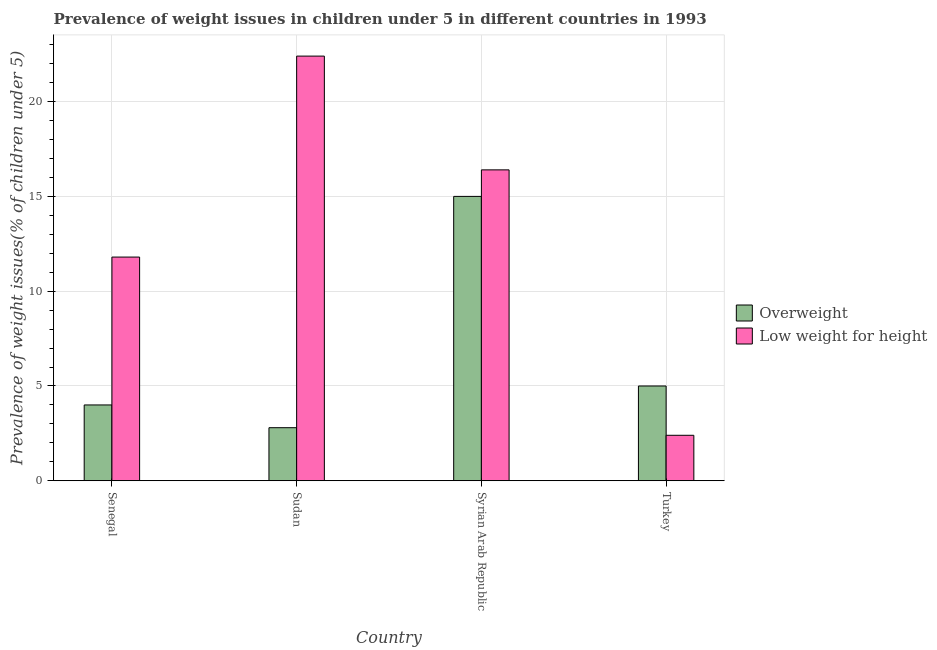Are the number of bars per tick equal to the number of legend labels?
Your answer should be very brief. Yes. Are the number of bars on each tick of the X-axis equal?
Your answer should be very brief. Yes. How many bars are there on the 1st tick from the left?
Your answer should be compact. 2. What is the label of the 4th group of bars from the left?
Keep it short and to the point. Turkey. In how many cases, is the number of bars for a given country not equal to the number of legend labels?
Your answer should be very brief. 0. Across all countries, what is the maximum percentage of overweight children?
Your response must be concise. 15. Across all countries, what is the minimum percentage of underweight children?
Your answer should be compact. 2.4. In which country was the percentage of underweight children maximum?
Provide a short and direct response. Sudan. In which country was the percentage of underweight children minimum?
Offer a very short reply. Turkey. What is the total percentage of underweight children in the graph?
Provide a succinct answer. 53. What is the difference between the percentage of overweight children in Senegal and that in Syrian Arab Republic?
Provide a short and direct response. -11. What is the difference between the percentage of underweight children in Sudan and the percentage of overweight children in Turkey?
Offer a very short reply. 17.4. What is the average percentage of overweight children per country?
Your answer should be very brief. 6.7. What is the difference between the percentage of underweight children and percentage of overweight children in Turkey?
Offer a very short reply. -2.6. What is the ratio of the percentage of overweight children in Senegal to that in Sudan?
Ensure brevity in your answer.  1.43. Is the difference between the percentage of underweight children in Senegal and Sudan greater than the difference between the percentage of overweight children in Senegal and Sudan?
Your answer should be compact. No. What is the difference between the highest and the lowest percentage of overweight children?
Ensure brevity in your answer.  12.2. What does the 1st bar from the left in Sudan represents?
Your response must be concise. Overweight. What does the 2nd bar from the right in Sudan represents?
Provide a succinct answer. Overweight. How many countries are there in the graph?
Ensure brevity in your answer.  4. What is the difference between two consecutive major ticks on the Y-axis?
Provide a short and direct response. 5. Are the values on the major ticks of Y-axis written in scientific E-notation?
Make the answer very short. No. Does the graph contain any zero values?
Offer a very short reply. No. Does the graph contain grids?
Your answer should be very brief. Yes. Where does the legend appear in the graph?
Your answer should be compact. Center right. How many legend labels are there?
Your answer should be very brief. 2. What is the title of the graph?
Ensure brevity in your answer.  Prevalence of weight issues in children under 5 in different countries in 1993. What is the label or title of the Y-axis?
Make the answer very short. Prevalence of weight issues(% of children under 5). What is the Prevalence of weight issues(% of children under 5) of Low weight for height in Senegal?
Offer a terse response. 11.8. What is the Prevalence of weight issues(% of children under 5) in Overweight in Sudan?
Your answer should be compact. 2.8. What is the Prevalence of weight issues(% of children under 5) in Low weight for height in Sudan?
Offer a very short reply. 22.4. What is the Prevalence of weight issues(% of children under 5) of Overweight in Syrian Arab Republic?
Your response must be concise. 15. What is the Prevalence of weight issues(% of children under 5) in Low weight for height in Syrian Arab Republic?
Your answer should be compact. 16.4. What is the Prevalence of weight issues(% of children under 5) of Low weight for height in Turkey?
Ensure brevity in your answer.  2.4. Across all countries, what is the maximum Prevalence of weight issues(% of children under 5) of Overweight?
Your answer should be compact. 15. Across all countries, what is the maximum Prevalence of weight issues(% of children under 5) of Low weight for height?
Your answer should be compact. 22.4. Across all countries, what is the minimum Prevalence of weight issues(% of children under 5) of Overweight?
Offer a terse response. 2.8. Across all countries, what is the minimum Prevalence of weight issues(% of children under 5) of Low weight for height?
Make the answer very short. 2.4. What is the total Prevalence of weight issues(% of children under 5) of Overweight in the graph?
Give a very brief answer. 26.8. What is the total Prevalence of weight issues(% of children under 5) in Low weight for height in the graph?
Keep it short and to the point. 53. What is the difference between the Prevalence of weight issues(% of children under 5) of Overweight in Senegal and that in Syrian Arab Republic?
Your answer should be compact. -11. What is the difference between the Prevalence of weight issues(% of children under 5) of Low weight for height in Senegal and that in Syrian Arab Republic?
Offer a terse response. -4.6. What is the difference between the Prevalence of weight issues(% of children under 5) in Overweight in Sudan and that in Syrian Arab Republic?
Make the answer very short. -12.2. What is the difference between the Prevalence of weight issues(% of children under 5) of Overweight in Sudan and that in Turkey?
Ensure brevity in your answer.  -2.2. What is the difference between the Prevalence of weight issues(% of children under 5) of Low weight for height in Sudan and that in Turkey?
Your answer should be compact. 20. What is the difference between the Prevalence of weight issues(% of children under 5) of Overweight in Senegal and the Prevalence of weight issues(% of children under 5) of Low weight for height in Sudan?
Provide a succinct answer. -18.4. What is the difference between the Prevalence of weight issues(% of children under 5) in Overweight in Sudan and the Prevalence of weight issues(% of children under 5) in Low weight for height in Turkey?
Ensure brevity in your answer.  0.4. What is the difference between the Prevalence of weight issues(% of children under 5) of Overweight in Syrian Arab Republic and the Prevalence of weight issues(% of children under 5) of Low weight for height in Turkey?
Offer a very short reply. 12.6. What is the average Prevalence of weight issues(% of children under 5) in Low weight for height per country?
Keep it short and to the point. 13.25. What is the difference between the Prevalence of weight issues(% of children under 5) in Overweight and Prevalence of weight issues(% of children under 5) in Low weight for height in Senegal?
Offer a terse response. -7.8. What is the difference between the Prevalence of weight issues(% of children under 5) in Overweight and Prevalence of weight issues(% of children under 5) in Low weight for height in Sudan?
Make the answer very short. -19.6. What is the ratio of the Prevalence of weight issues(% of children under 5) in Overweight in Senegal to that in Sudan?
Your answer should be compact. 1.43. What is the ratio of the Prevalence of weight issues(% of children under 5) of Low weight for height in Senegal to that in Sudan?
Give a very brief answer. 0.53. What is the ratio of the Prevalence of weight issues(% of children under 5) of Overweight in Senegal to that in Syrian Arab Republic?
Provide a short and direct response. 0.27. What is the ratio of the Prevalence of weight issues(% of children under 5) of Low weight for height in Senegal to that in Syrian Arab Republic?
Offer a terse response. 0.72. What is the ratio of the Prevalence of weight issues(% of children under 5) of Overweight in Senegal to that in Turkey?
Offer a very short reply. 0.8. What is the ratio of the Prevalence of weight issues(% of children under 5) of Low weight for height in Senegal to that in Turkey?
Give a very brief answer. 4.92. What is the ratio of the Prevalence of weight issues(% of children under 5) in Overweight in Sudan to that in Syrian Arab Republic?
Make the answer very short. 0.19. What is the ratio of the Prevalence of weight issues(% of children under 5) in Low weight for height in Sudan to that in Syrian Arab Republic?
Your response must be concise. 1.37. What is the ratio of the Prevalence of weight issues(% of children under 5) of Overweight in Sudan to that in Turkey?
Make the answer very short. 0.56. What is the ratio of the Prevalence of weight issues(% of children under 5) in Low weight for height in Sudan to that in Turkey?
Make the answer very short. 9.33. What is the ratio of the Prevalence of weight issues(% of children under 5) in Overweight in Syrian Arab Republic to that in Turkey?
Your response must be concise. 3. What is the ratio of the Prevalence of weight issues(% of children under 5) in Low weight for height in Syrian Arab Republic to that in Turkey?
Offer a very short reply. 6.83. What is the difference between the highest and the lowest Prevalence of weight issues(% of children under 5) in Overweight?
Your answer should be very brief. 12.2. What is the difference between the highest and the lowest Prevalence of weight issues(% of children under 5) of Low weight for height?
Give a very brief answer. 20. 